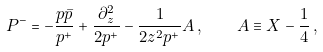<formula> <loc_0><loc_0><loc_500><loc_500>P ^ { - } = - \frac { p \bar { p } } { p ^ { + } } + \frac { \partial ^ { 2 } _ { z } } { 2 p ^ { + } } - \frac { 1 } { 2 z ^ { 2 } p ^ { + } } A \, , \quad A \equiv X - \frac { 1 } { 4 } \, ,</formula> 